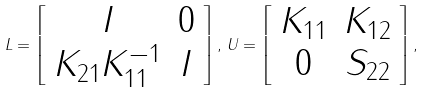<formula> <loc_0><loc_0><loc_500><loc_500>L = \left [ \begin{array} { c c } I & 0 \\ K _ { 2 1 } K ^ { - 1 } _ { 1 1 } & I \end{array} \right ] , \, U = \left [ \begin{array} { c c } K _ { 1 1 } & K _ { 1 2 } \\ 0 & S _ { 2 2 } \end{array} \right ] ,</formula> 